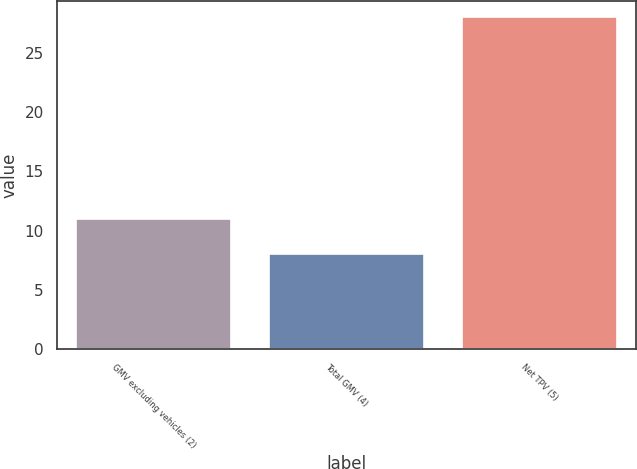<chart> <loc_0><loc_0><loc_500><loc_500><bar_chart><fcel>GMV excluding vehicles (2)<fcel>Total GMV (4)<fcel>Net TPV (5)<nl><fcel>11<fcel>8<fcel>28<nl></chart> 